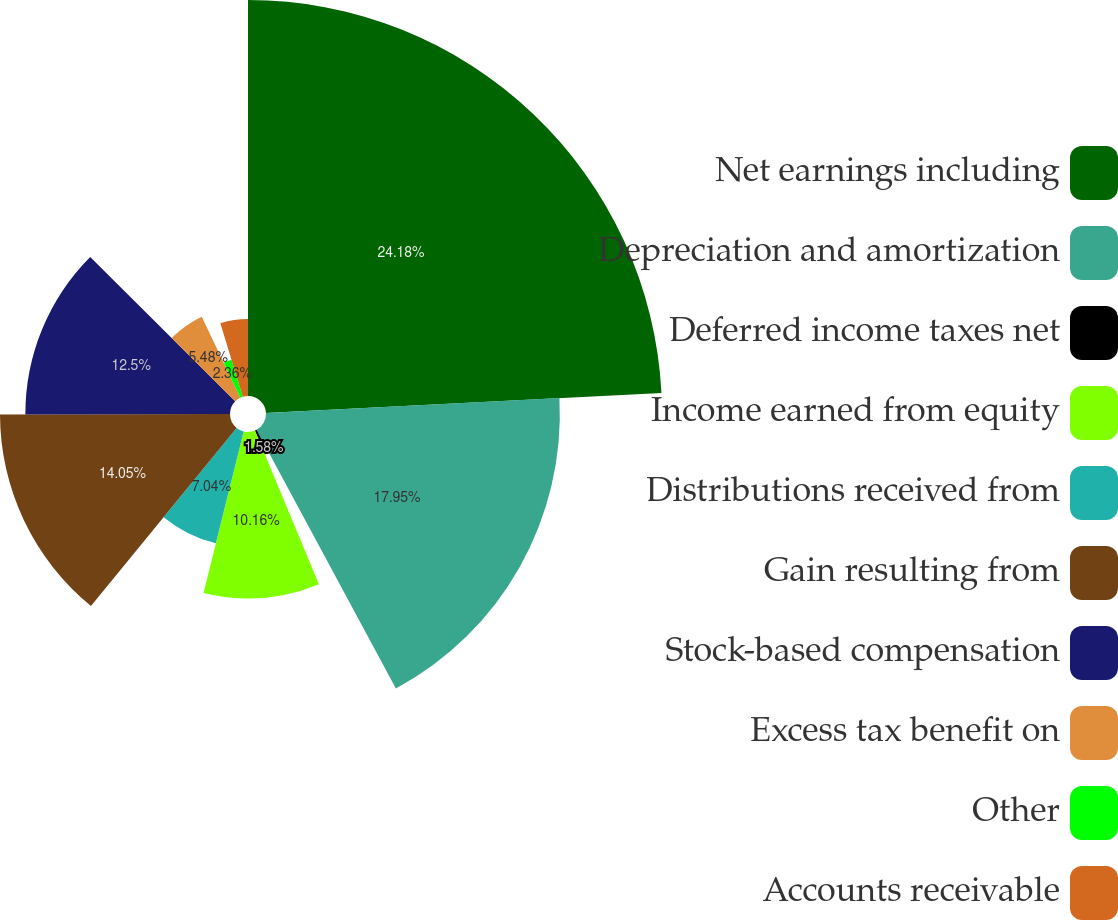Convert chart to OTSL. <chart><loc_0><loc_0><loc_500><loc_500><pie_chart><fcel>Net earnings including<fcel>Depreciation and amortization<fcel>Deferred income taxes net<fcel>Income earned from equity<fcel>Distributions received from<fcel>Gain resulting from<fcel>Stock-based compensation<fcel>Excess tax benefit on<fcel>Other<fcel>Accounts receivable<nl><fcel>24.19%<fcel>17.95%<fcel>1.58%<fcel>10.16%<fcel>7.04%<fcel>14.05%<fcel>12.5%<fcel>5.48%<fcel>2.36%<fcel>4.7%<nl></chart> 